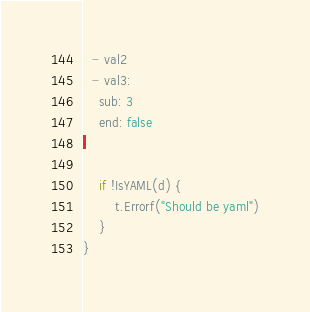Convert code to text. <code><loc_0><loc_0><loc_500><loc_500><_Go_>  - val2
  - val3:
    sub: 3
    end: false
`

	if !IsYAML(d) {
		t.Errorf("Should be yaml")
	}
}
</code> 